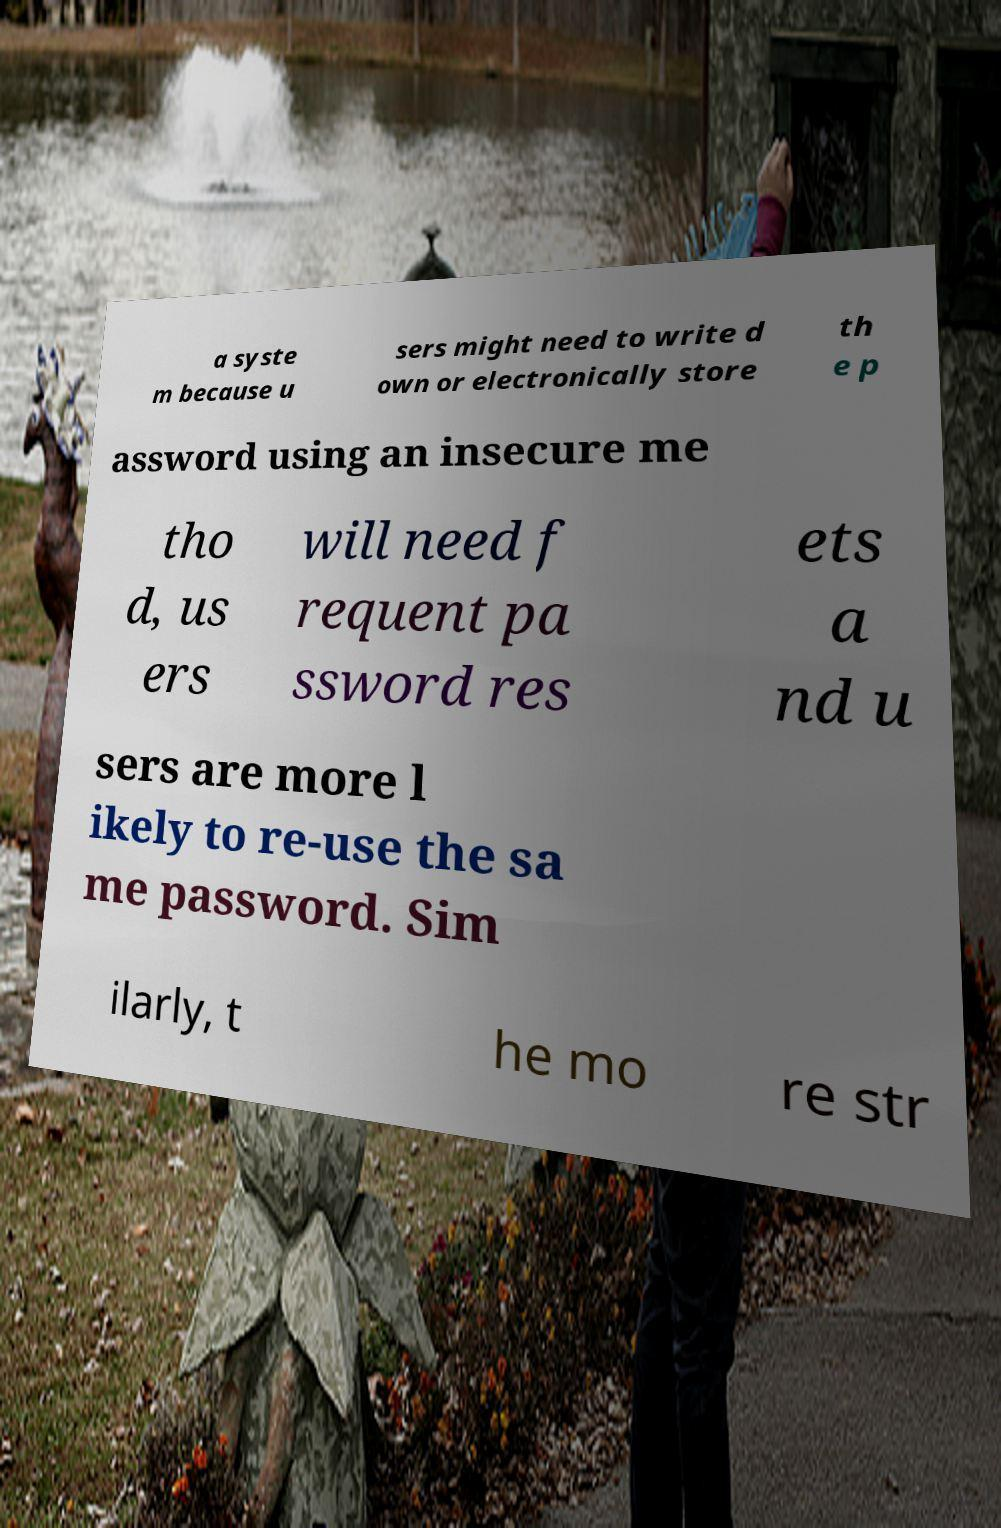What messages or text are displayed in this image? I need them in a readable, typed format. a syste m because u sers might need to write d own or electronically store th e p assword using an insecure me tho d, us ers will need f requent pa ssword res ets a nd u sers are more l ikely to re-use the sa me password. Sim ilarly, t he mo re str 